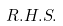<formula> <loc_0><loc_0><loc_500><loc_500>R . H . S .</formula> 